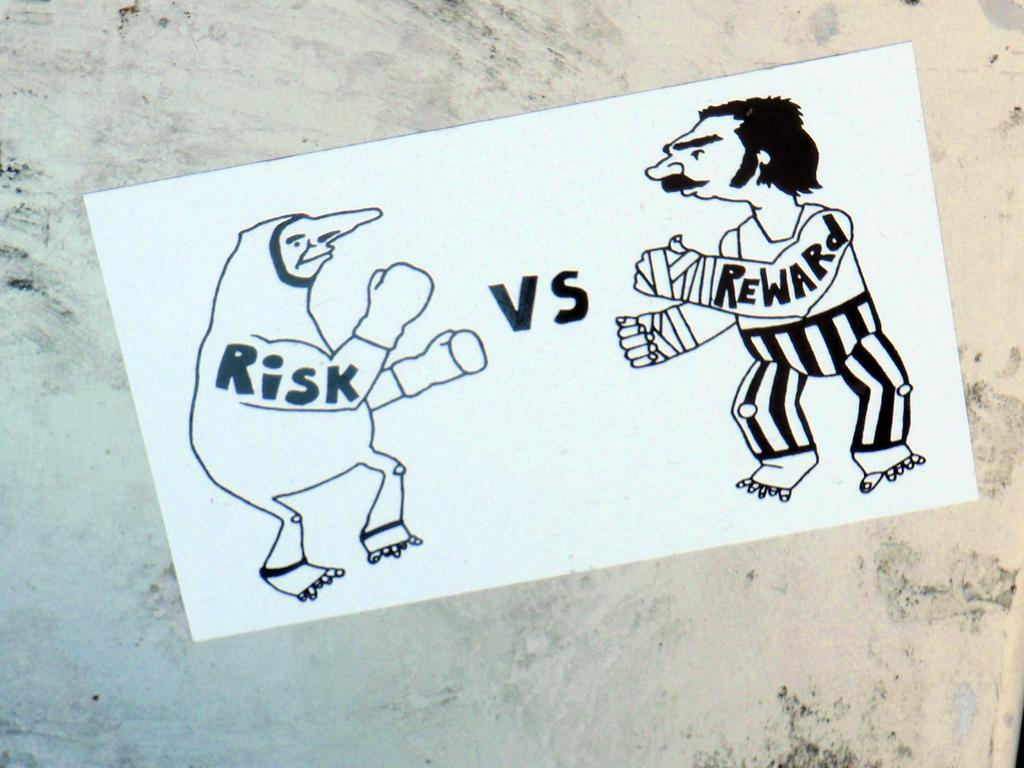What is depicted on the paper in the image? There is a drawing on a paper in the image. What else is present on the paper besides the drawing? There is text on the paper. Where is the paper located in the image? The paper is placed on a surface. What type of twig is being used to create the drawing on the paper? There is no twig present in the image; the drawing is likely made with a pen, pencil, or other drawing tool. 